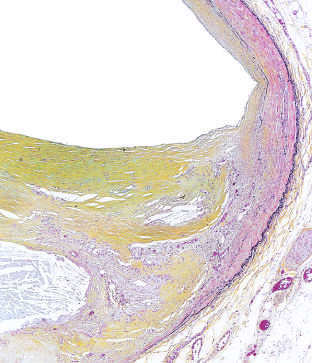s energy stores thinned under the most advanced plaque?
Answer the question using a single word or phrase. No 